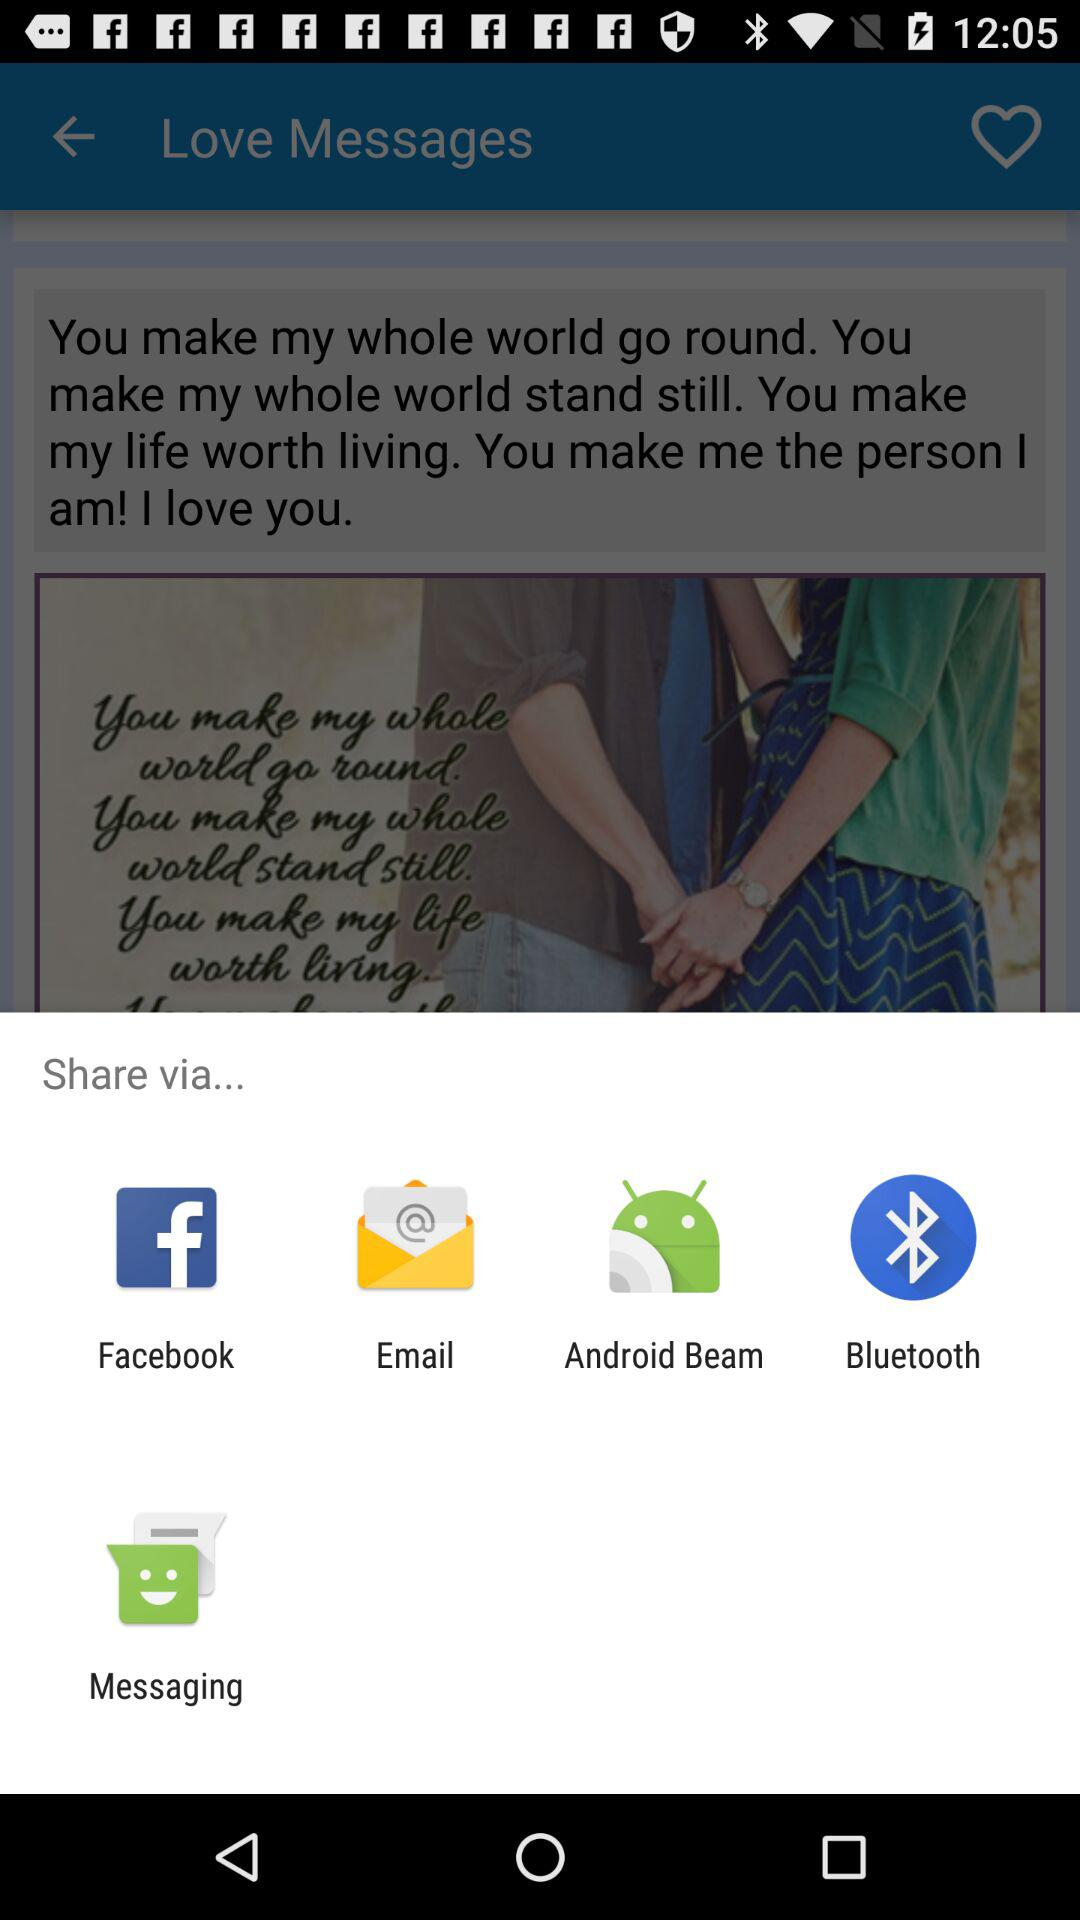What is the username?
When the provided information is insufficient, respond with <no answer>. <no answer> 